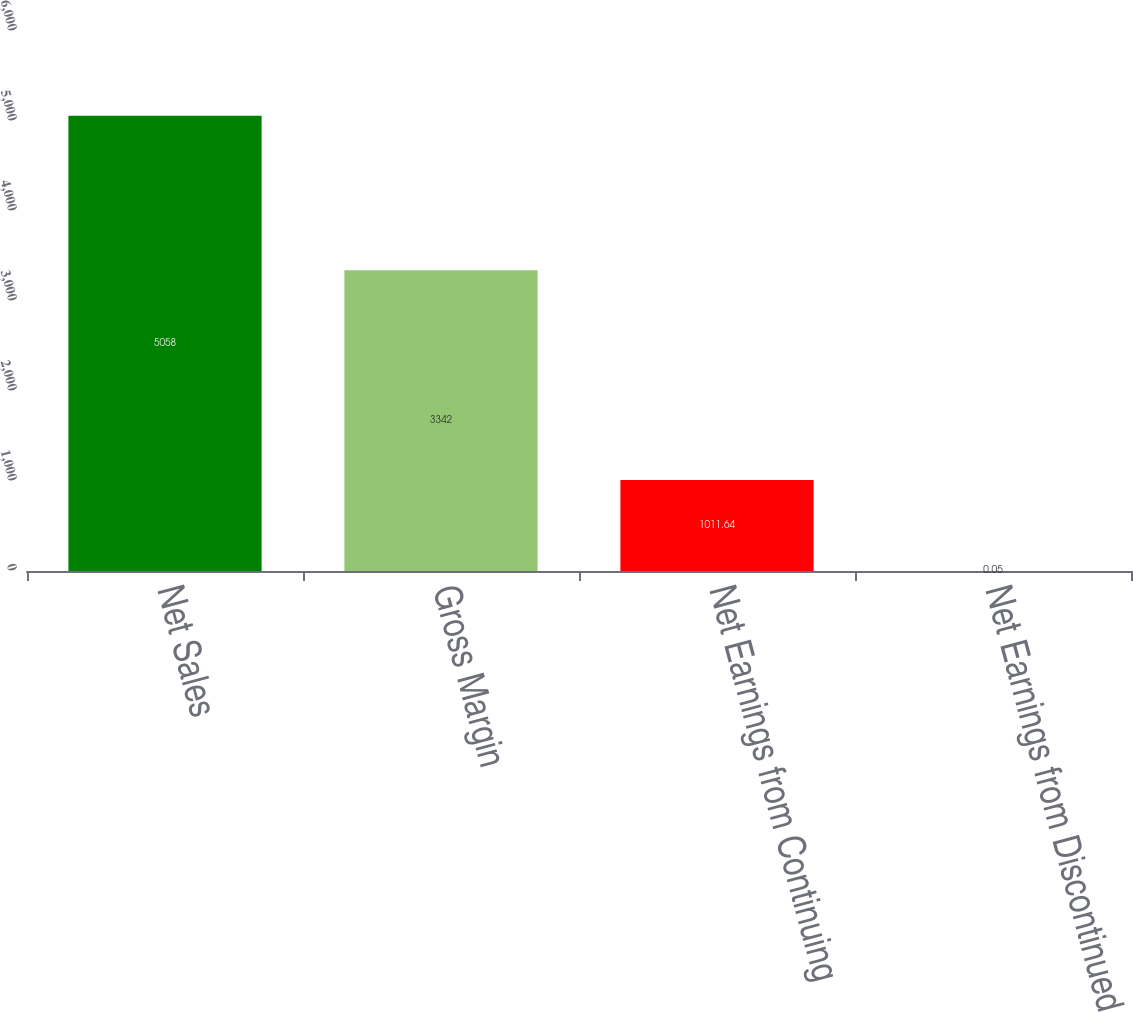Convert chart to OTSL. <chart><loc_0><loc_0><loc_500><loc_500><bar_chart><fcel>Net Sales<fcel>Gross Margin<fcel>Net Earnings from Continuing<fcel>Net Earnings from Discontinued<nl><fcel>5058<fcel>3342<fcel>1011.64<fcel>0.05<nl></chart> 